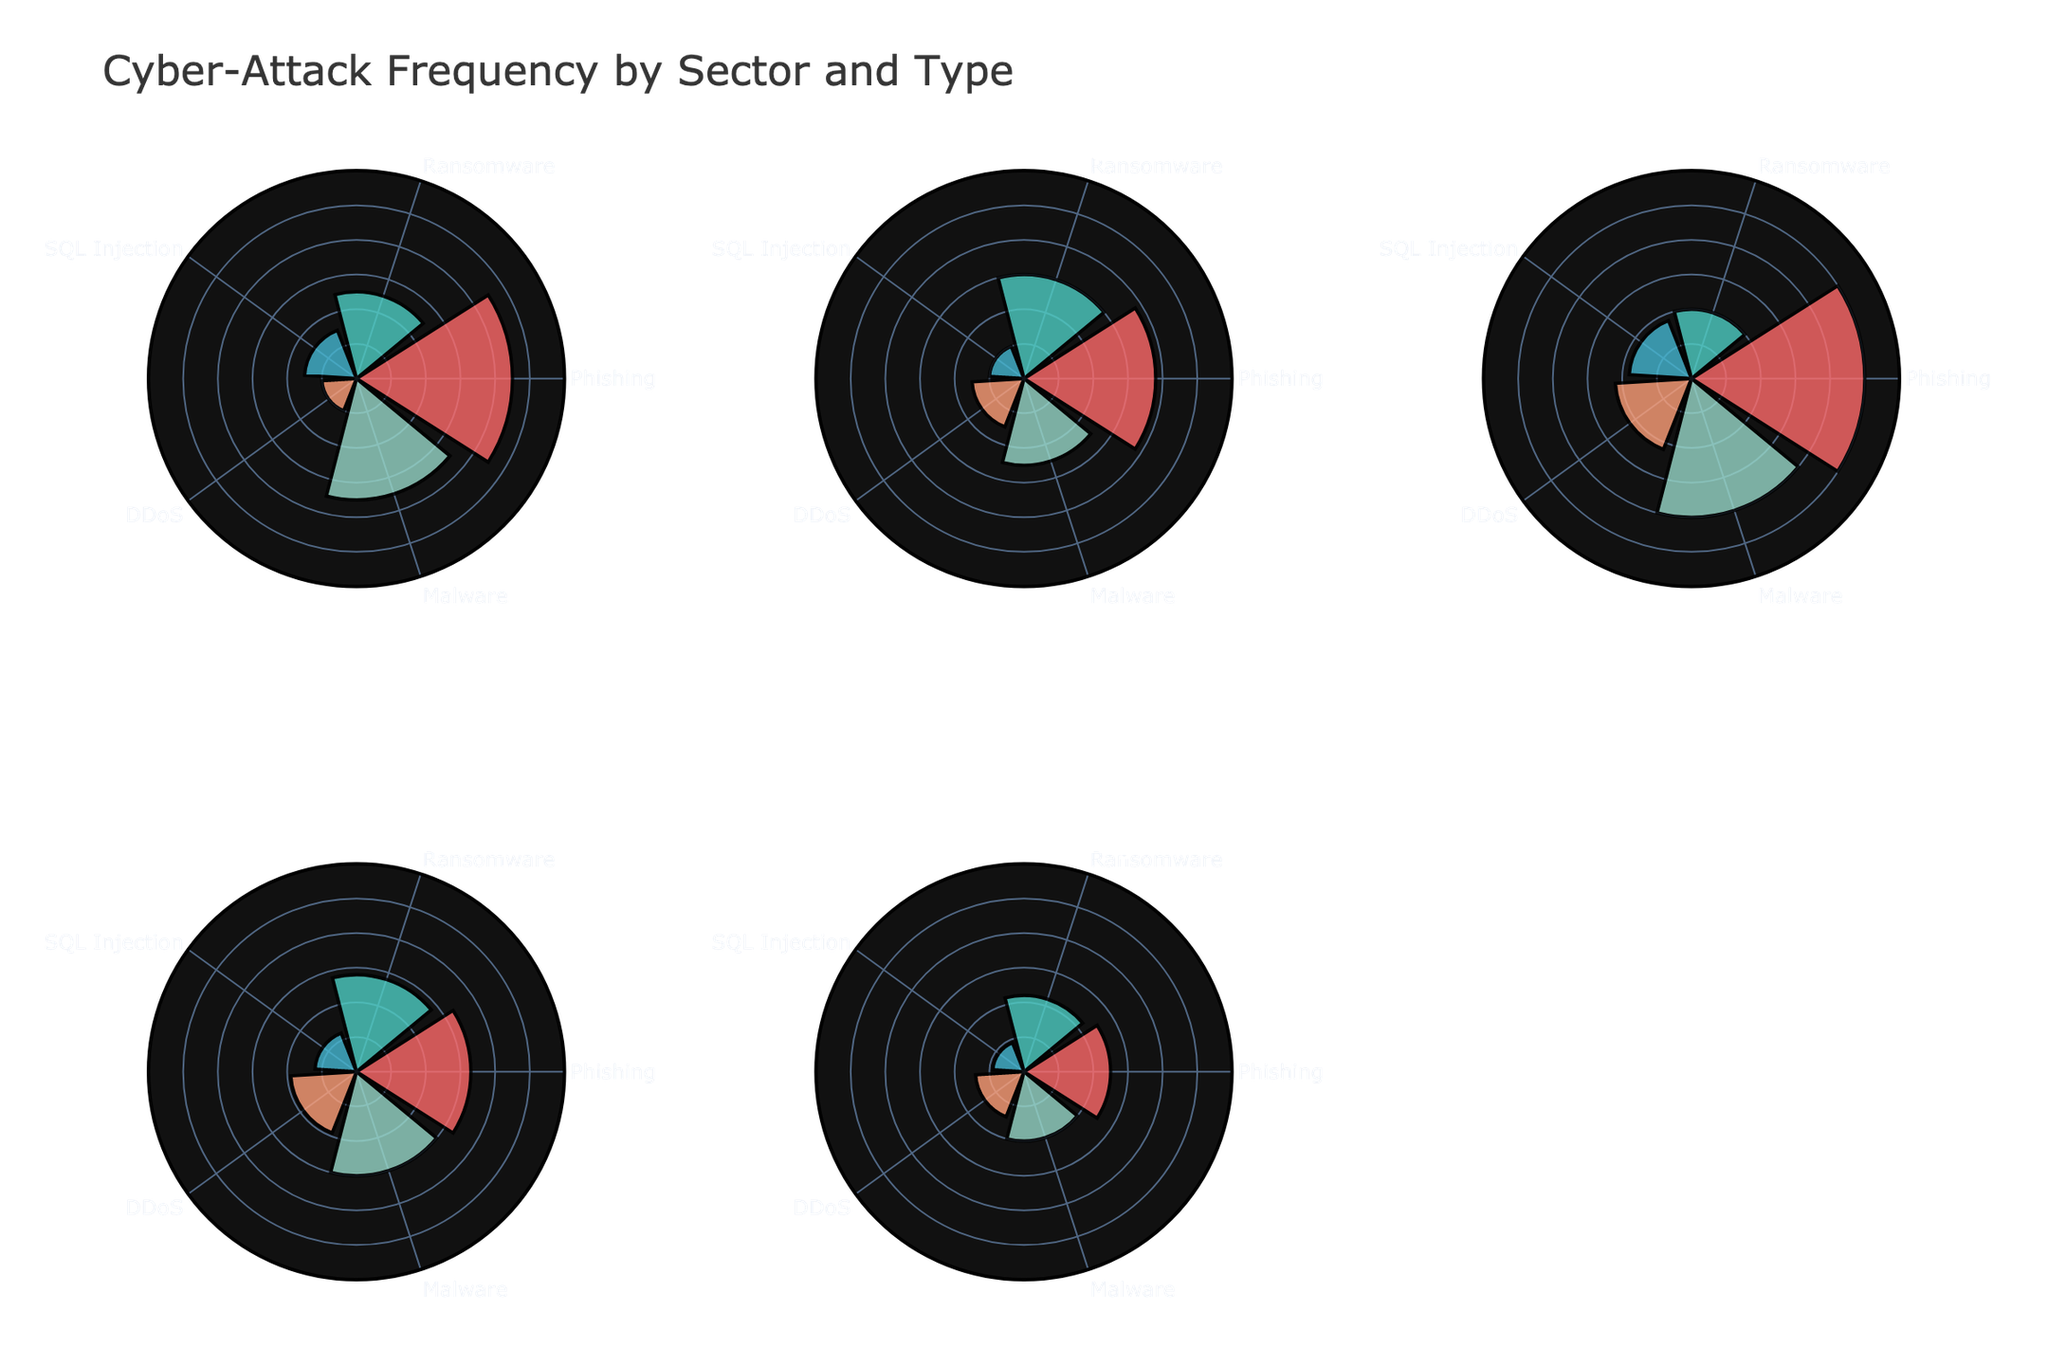Which sector experiences the highest frequency of Phishing attacks? Looking at the subplot corresponding to the Finance sector, we observe that the bar representing Phishing has the highest radius. This observation is confirmed by comparing the bars of Phishing across all sectors.
Answer: Retail Which type of attack is least frequent in the Healthcare sector? In the Healthcare subplot, the bar representing SQL Injection has the smallest radius among all attack types.
Answer: SQL Injection Which attack type shows the most variation in frequency across all sectors? By comparing the bar lengths for each attack type across all subplots, Phishing shows the most variation with significant differences in bar lengths across the sectors.
Answer: Phishing What is the total frequency of Ransomware attacks across all sectors? Add the frequency of Ransomware attacks from each sector: 25 (Finance) + 30 (Healthcare) + 20 (Retail) + 28 (Government) + 22 (Manufacturing) = 125
Answer: 125 How does the frequency of DDoS attacks in Manufacturing compare to that in Government? Locate the DDoS bar in both the Manufacturing and Government subplots. The DDoS in Manufacturing is shorter, indicating a lower frequency compared to that in Government.
Answer: Lower Is there any sector where Phishing is not the most frequent attack type? By examining each subplot, Healthcare and Finance have Phishing as the most frequent attack; however, Retail also has Phishing as the most frequent, while Government and Manufacturing have it too. Thus, no sector lacks Phishing as the most frequent.
Answer: No Which sector has the least frequency of SQL Injection attacks? In the Manufacturing subplot, the SQL Injection bar has the smallest radius among all sectors, indicating the lowest frequency.
Answer: Manufacturing What is the difference in the frequency of Malware attacks between Retail and Government sectors? Check the Malware bars in both Retail (40) and Government (30) subplots. The difference is 40 - 30 = 10.
Answer: 10 Which sector has the second-highest number of Malware attacks? Comparing the bars in all sectors for Malware, Finance ranks the highest, followed by Retail with a frequency of 40.
Answer: Retail Is Phishing the most frequent attack type for all sectors? Observing all the subplots, Phishing shows the highest frequency across Finance, Healthcare, Retail, Government, and Manufacturing sectors.
Answer: Yes 